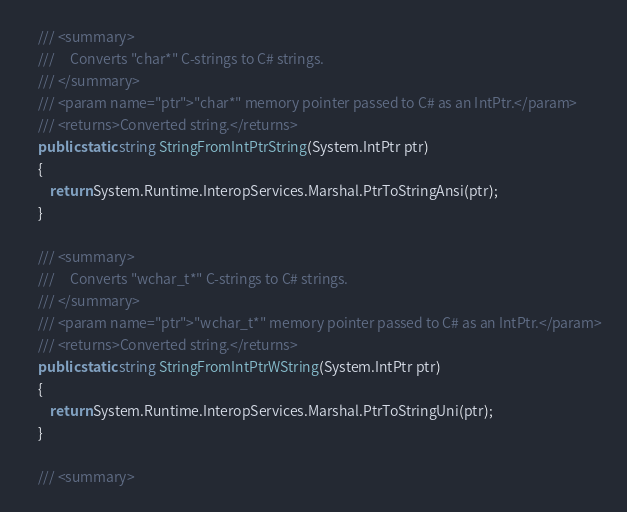<code> <loc_0><loc_0><loc_500><loc_500><_C#_>
	/// <summary>
	///     Converts "char*" C-strings to C# strings.
	/// </summary>
	/// <param name="ptr">"char*" memory pointer passed to C# as an IntPtr.</param>
	/// <returns>Converted string.</returns>
	public static string StringFromIntPtrString(System.IntPtr ptr)
	{
		return System.Runtime.InteropServices.Marshal.PtrToStringAnsi(ptr);
	}

	/// <summary>
	///     Converts "wchar_t*" C-strings to C# strings.
	/// </summary>
	/// <param name="ptr">"wchar_t*" memory pointer passed to C# as an IntPtr.</param>
	/// <returns>Converted string.</returns>
	public static string StringFromIntPtrWString(System.IntPtr ptr)
	{
		return System.Runtime.InteropServices.Marshal.PtrToStringUni(ptr);
	}

	/// <summary></code> 